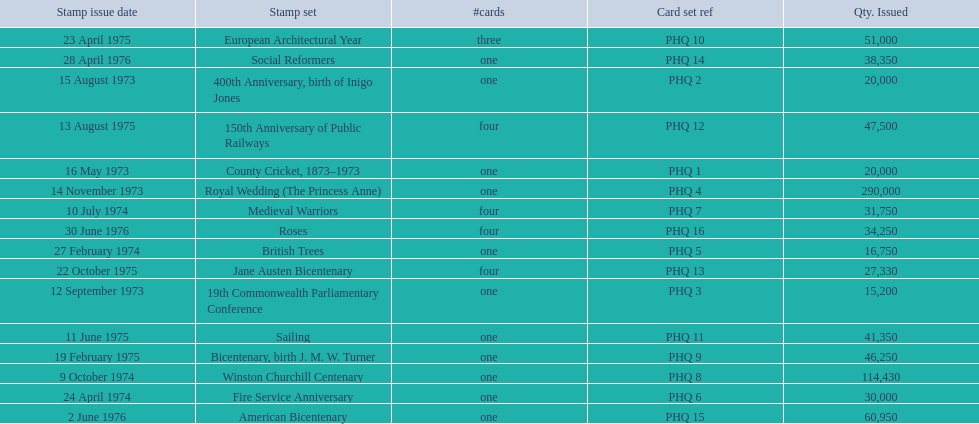Which stamp collection had the largest number released? Royal Wedding (The Princess Anne). 